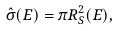Convert formula to latex. <formula><loc_0><loc_0><loc_500><loc_500>\hat { \sigma } ( E ) = \pi R _ { S } ^ { 2 } ( E ) ,</formula> 